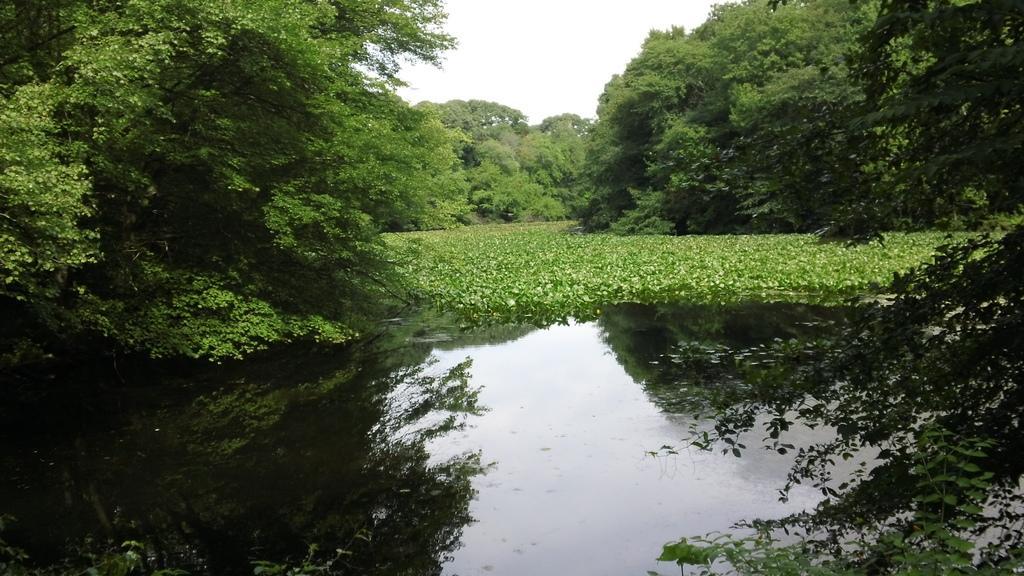How would you summarize this image in a sentence or two? In this image, we can see plants, water and trees. Background we can see the sky. On the water, we can see reflections. 